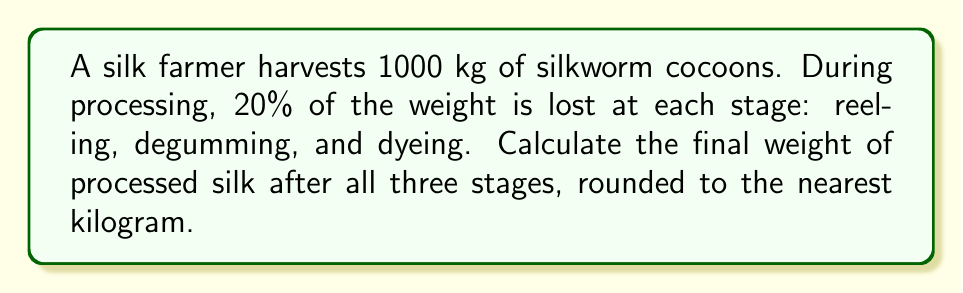Give your solution to this math problem. Let's approach this step-by-step:

1) Initial weight of cocoons: 1000 kg

2) After reeling (first stage):
   $1000 \times (1 - 0.20) = 1000 \times 0.80 = 800$ kg

3) After degumming (second stage):
   $800 \times (1 - 0.20) = 800 \times 0.80 = 640$ kg

4) After dyeing (third stage):
   $640 \times (1 - 0.20) = 640 \times 0.80 = 512$ kg

5) The final weight can be calculated in one step:
   $$1000 \times (0.80)^3 = 1000 \times 0.512 = 512$$ kg

6) Rounding to the nearest kilogram:
   512 kg (no rounding needed)

Therefore, the final weight of processed silk after all three stages is 512 kg.
Answer: 512 kg 